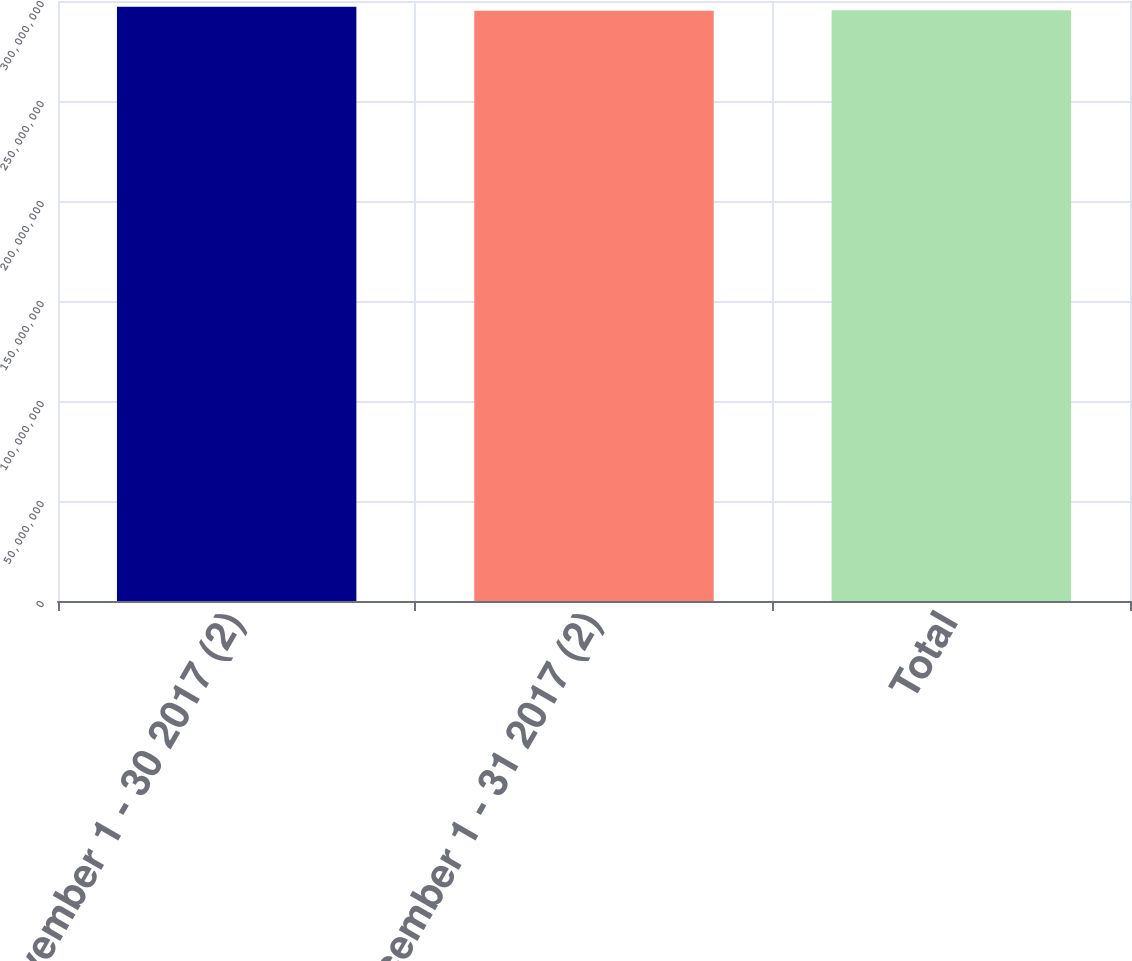Convert chart to OTSL. <chart><loc_0><loc_0><loc_500><loc_500><bar_chart><fcel>November 1 - 30 2017 (2)<fcel>December 1 - 31 2017 (2)<fcel>Total<nl><fcel>2.97121e+08<fcel>2.95141e+08<fcel>2.95339e+08<nl></chart> 